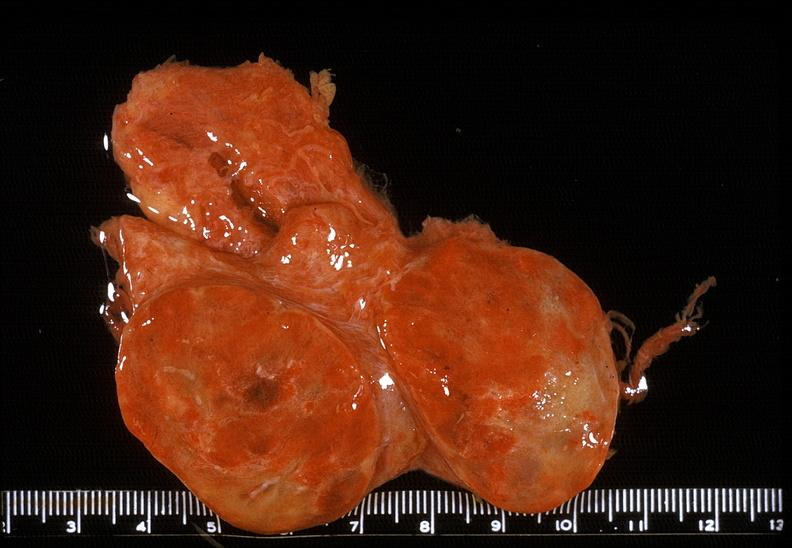what does this image show?
Answer the question using a single word or phrase. Thyroid 